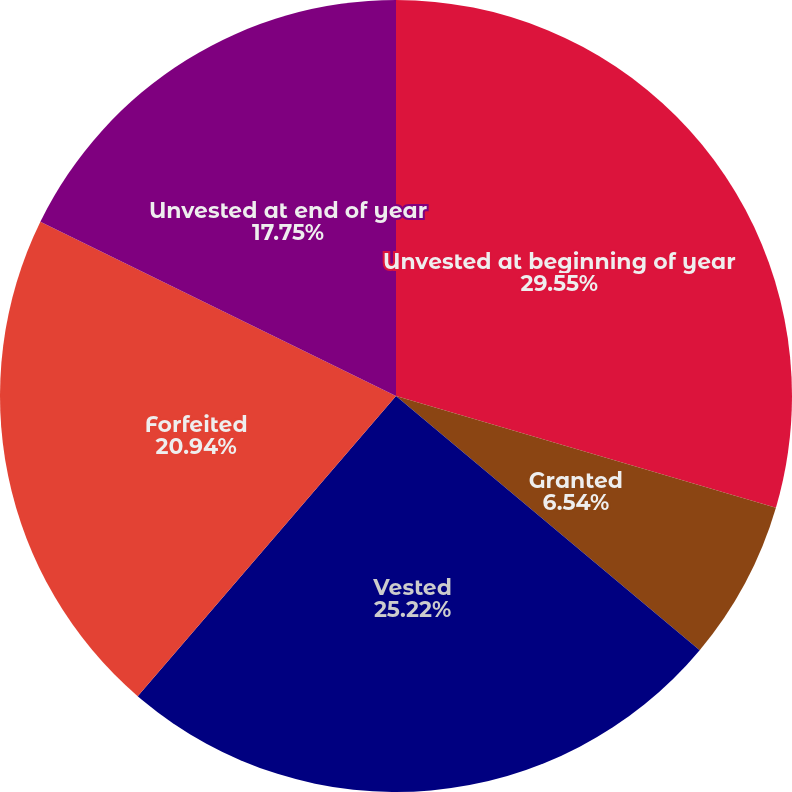Convert chart to OTSL. <chart><loc_0><loc_0><loc_500><loc_500><pie_chart><fcel>Unvested at beginning of year<fcel>Granted<fcel>Vested<fcel>Forfeited<fcel>Unvested at end of year<nl><fcel>29.55%<fcel>6.54%<fcel>25.22%<fcel>20.94%<fcel>17.75%<nl></chart> 